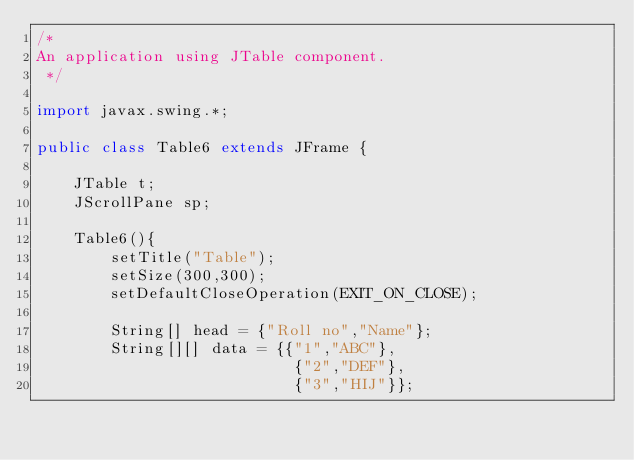<code> <loc_0><loc_0><loc_500><loc_500><_Java_>/*
An application using JTable component.
 */

import javax.swing.*;

public class Table6 extends JFrame {
    
    JTable t;
    JScrollPane sp;
    
    Table6(){
        setTitle("Table");
        setSize(300,300);
        setDefaultCloseOperation(EXIT_ON_CLOSE);
        
        String[] head = {"Roll no","Name"};
        String[][] data = {{"1","ABC"},
                            {"2","DEF"},
                            {"3","HIJ"}};
        </code> 